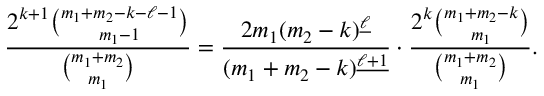<formula> <loc_0><loc_0><loc_500><loc_500>\frac { 2 ^ { k + 1 } \binom { m _ { 1 } + m _ { 2 } - k - \ell - 1 } { m _ { 1 } - 1 } } { \binom { m _ { 1 } + m _ { 2 } } { m _ { 1 } } } = \frac { 2 m _ { 1 } ( m _ { 2 } - k ) ^ { \underline { \ell } } } { ( m _ { 1 } + m _ { 2 } - k ) ^ { \underline { \ell + 1 } } } \cdot \frac { 2 ^ { k } \binom { m _ { 1 } + m _ { 2 } - k } { m _ { 1 } } } { \binom { m _ { 1 } + m _ { 2 } } { m _ { 1 } } } .</formula> 